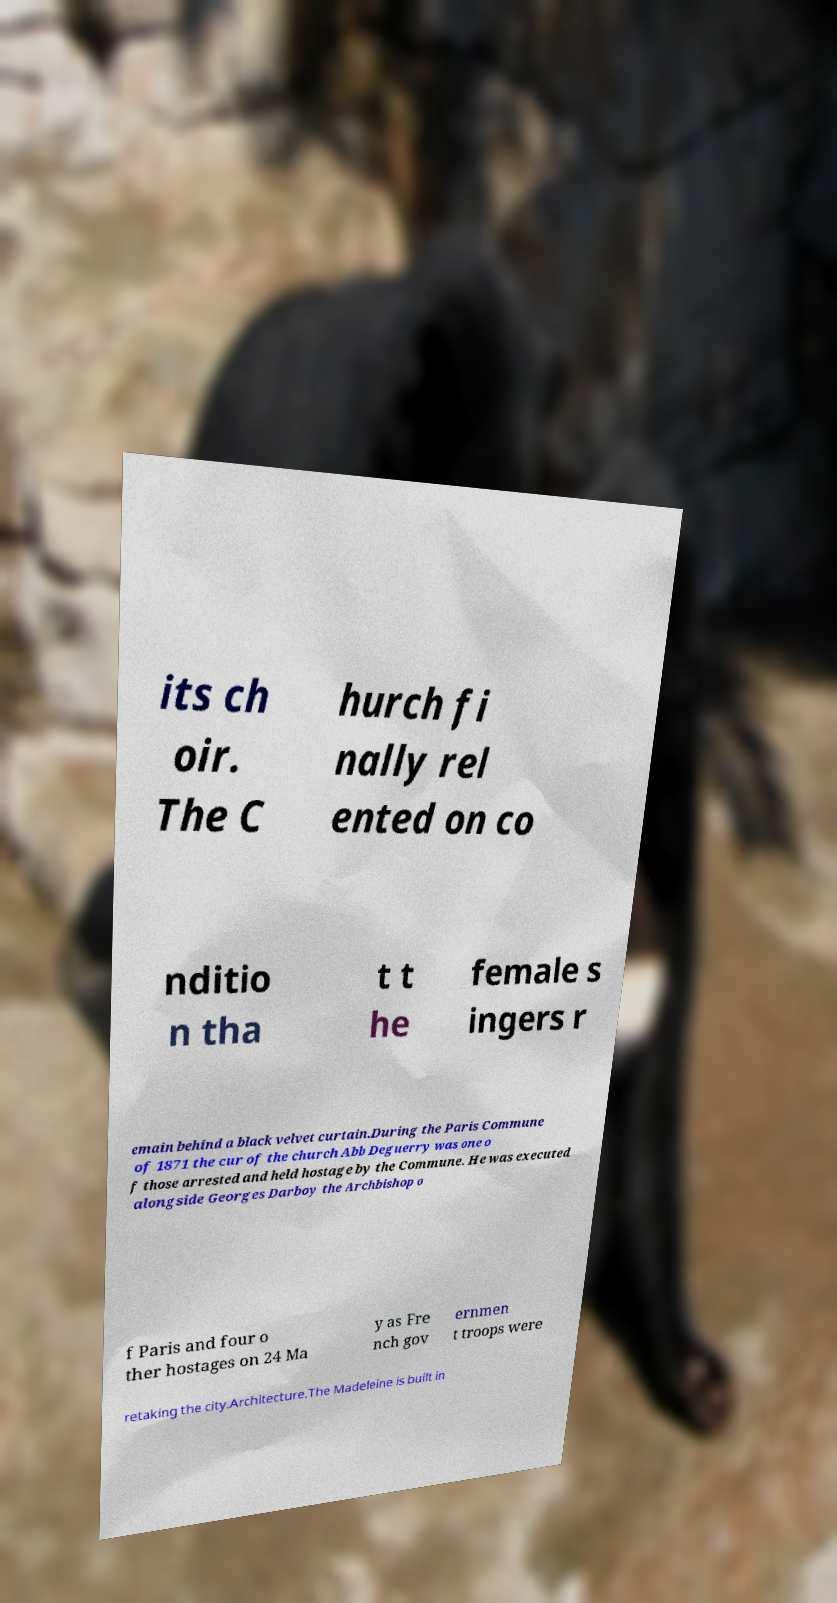Can you read and provide the text displayed in the image?This photo seems to have some interesting text. Can you extract and type it out for me? its ch oir. The C hurch fi nally rel ented on co nditio n tha t t he female s ingers r emain behind a black velvet curtain.During the Paris Commune of 1871 the cur of the church Abb Deguerry was one o f those arrested and held hostage by the Commune. He was executed alongside Georges Darboy the Archbishop o f Paris and four o ther hostages on 24 Ma y as Fre nch gov ernmen t troops were retaking the city.Architecture.The Madeleine is built in 